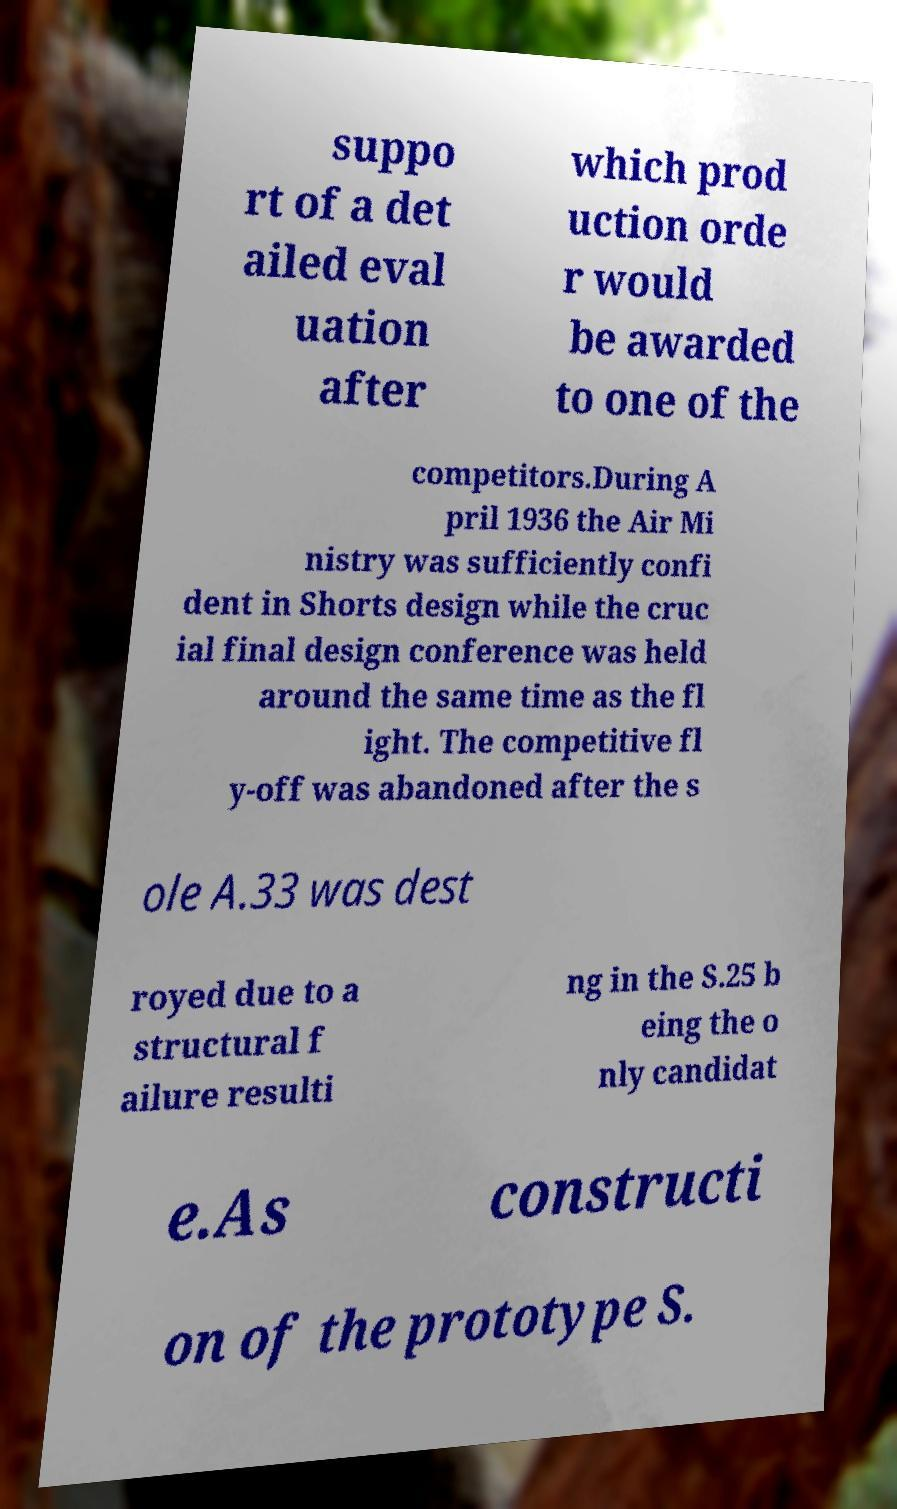Could you extract and type out the text from this image? suppo rt of a det ailed eval uation after which prod uction orde r would be awarded to one of the competitors.During A pril 1936 the Air Mi nistry was sufficiently confi dent in Shorts design while the cruc ial final design conference was held around the same time as the fl ight. The competitive fl y-off was abandoned after the s ole A.33 was dest royed due to a structural f ailure resulti ng in the S.25 b eing the o nly candidat e.As constructi on of the prototype S. 